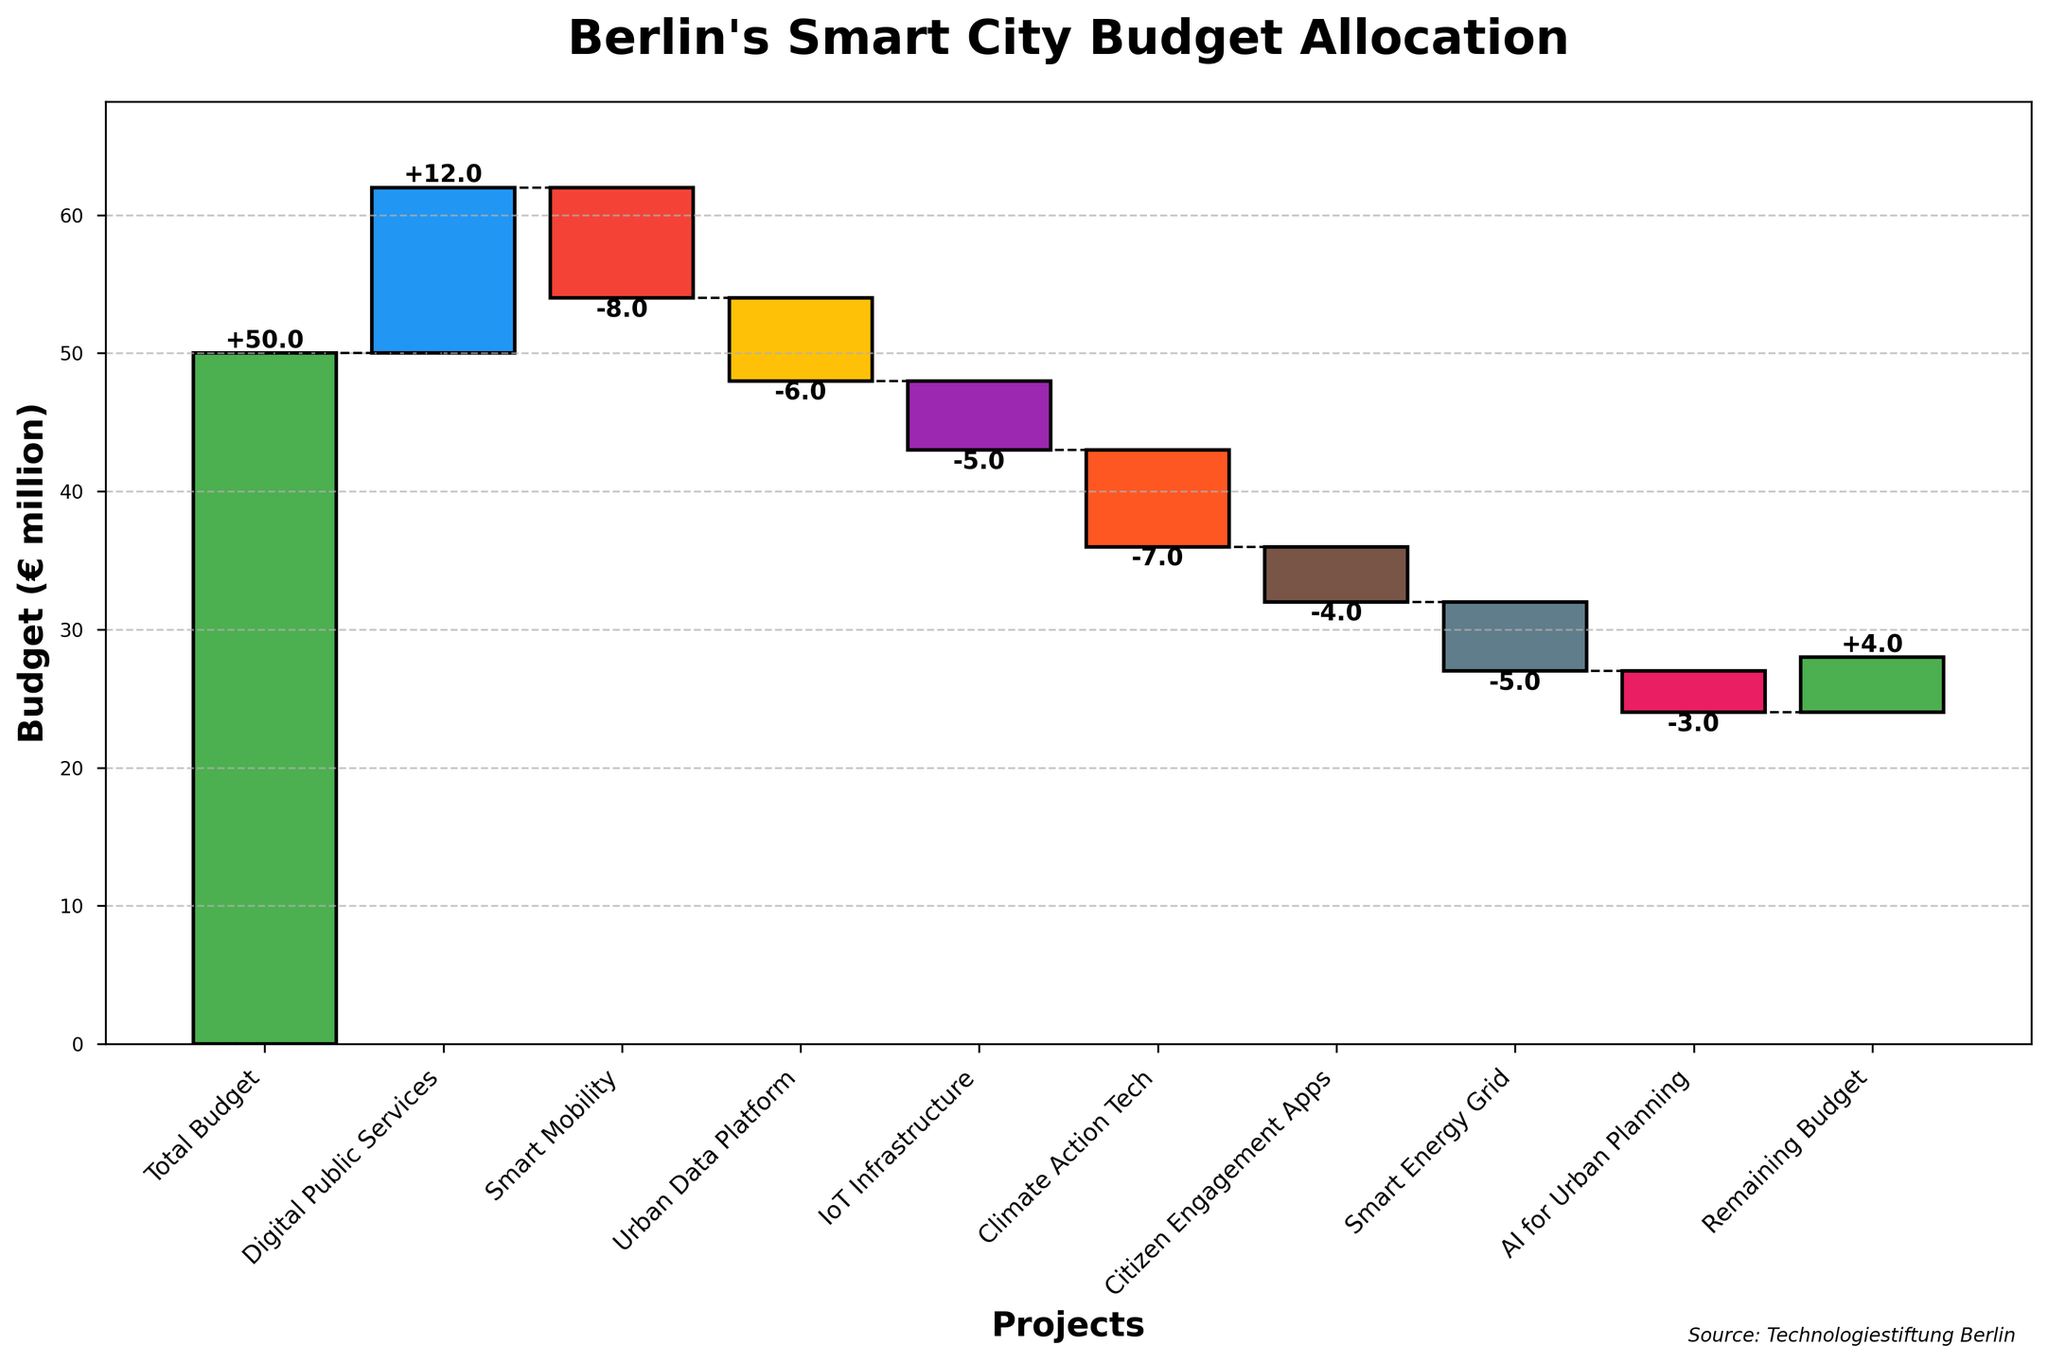What is the total budget allocated for Berlin's smart city initiatives? The title of the chart indicates that the total budget is €50 million. The 'Total Budget' column also confirms this by showing a budget value of 50.
Answer: €50 million Which project received the highest budget allocation? By looking at the heights of the bars, we can see that the 'Digital Public Services' received the highest allocation with €12 million.
Answer: Digital Public Services How much budget is remaining after allocating for all the projects? The 'Remaining Budget' column shows a value of 4 in the 'Budget (€ million)' column, which indicates €4 million is still unallocated.
Answer: €4 million What is the combined budget allocation for 'Climate Action Tech' and 'Smart Energy Grid'? The budgets for 'Climate Action Tech' and 'Smart Energy Grid' are -7 and -5 respectively. Summing these gives -7 + (-5) = -12.
Answer: -€12 million Which project has the smallest (most negative) budget allocation? The smallest bar belongs to the 'Smart Mobility' project with a budget allocation of -€8 million.
Answer: Smart Mobility How does the budget allocated to 'AI for Urban Planning' compare to 'Citizen Engagement Apps'? The 'Budgets (€ million)' for 'AI for Urban Planning' is -3, and for 'Citizen Engagement Apps' it is -4. Therefore, 'AI for Urban Planning' has a €1 million higher budget allocation compared to 'Citizen Engagement Apps'.
Answer: AI for Urban Planning Is the budget allocation for 'Smart Mobility' greater than 'Urban Data Platform'? The budget allocation for 'Smart Mobility' is -8, while for 'Urban Data Platform' it is -6. Since -8 is less than -6, the allocation for 'Smart Mobility' is smaller.
Answer: No How many projects received a negative budget allocation? By counting the bars that extend downward (negative values), we see that 'Smart Mobility', 'Urban Data Platform', 'IoT Infrastructure', 'Climate Action Tech', 'Citizen Engagement Apps', 'Smart Energy Grid', and 'AI for Urban Planning' have negative allocations. This totals 7 projects.
Answer: 7 What is the difference between the budget allocations of 'Digital Public Services' and 'Climate Action Tech'? The budget for 'Digital Public Services' is 12, and for 'Climate Action Tech' it is -7. The difference is 12 - (-7) = 12 + 7 = 19.
Answer: €19 million By how much does the 'Smart Mobility' budget allocation exceed the 'AI for Urban Planning' allocation? The 'Smart Mobility' allocation is -8, and 'AI for Urban Planning' is -3. The difference is -3 - (-8) = -3 + 8 = 5.
Answer: €5 million 